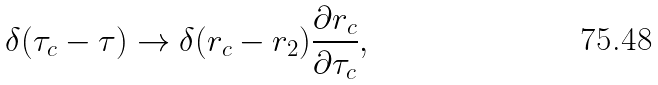<formula> <loc_0><loc_0><loc_500><loc_500>\delta ( \tau _ { c } - \tau ) \rightarrow \delta ( r _ { c } - r _ { 2 } ) \frac { \partial r _ { c } } { \partial \tau _ { c } } ,</formula> 